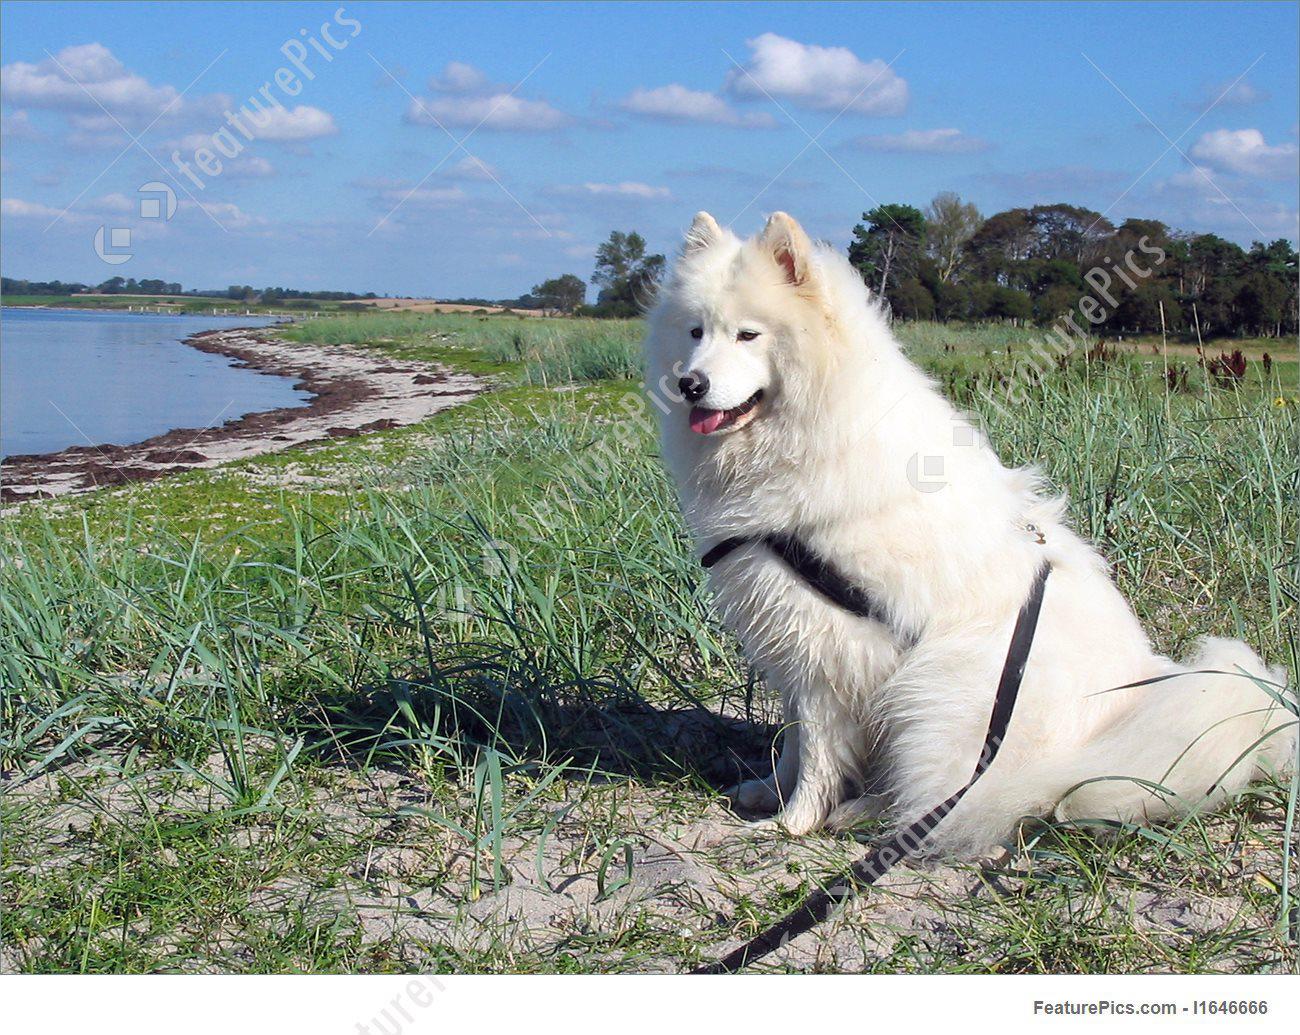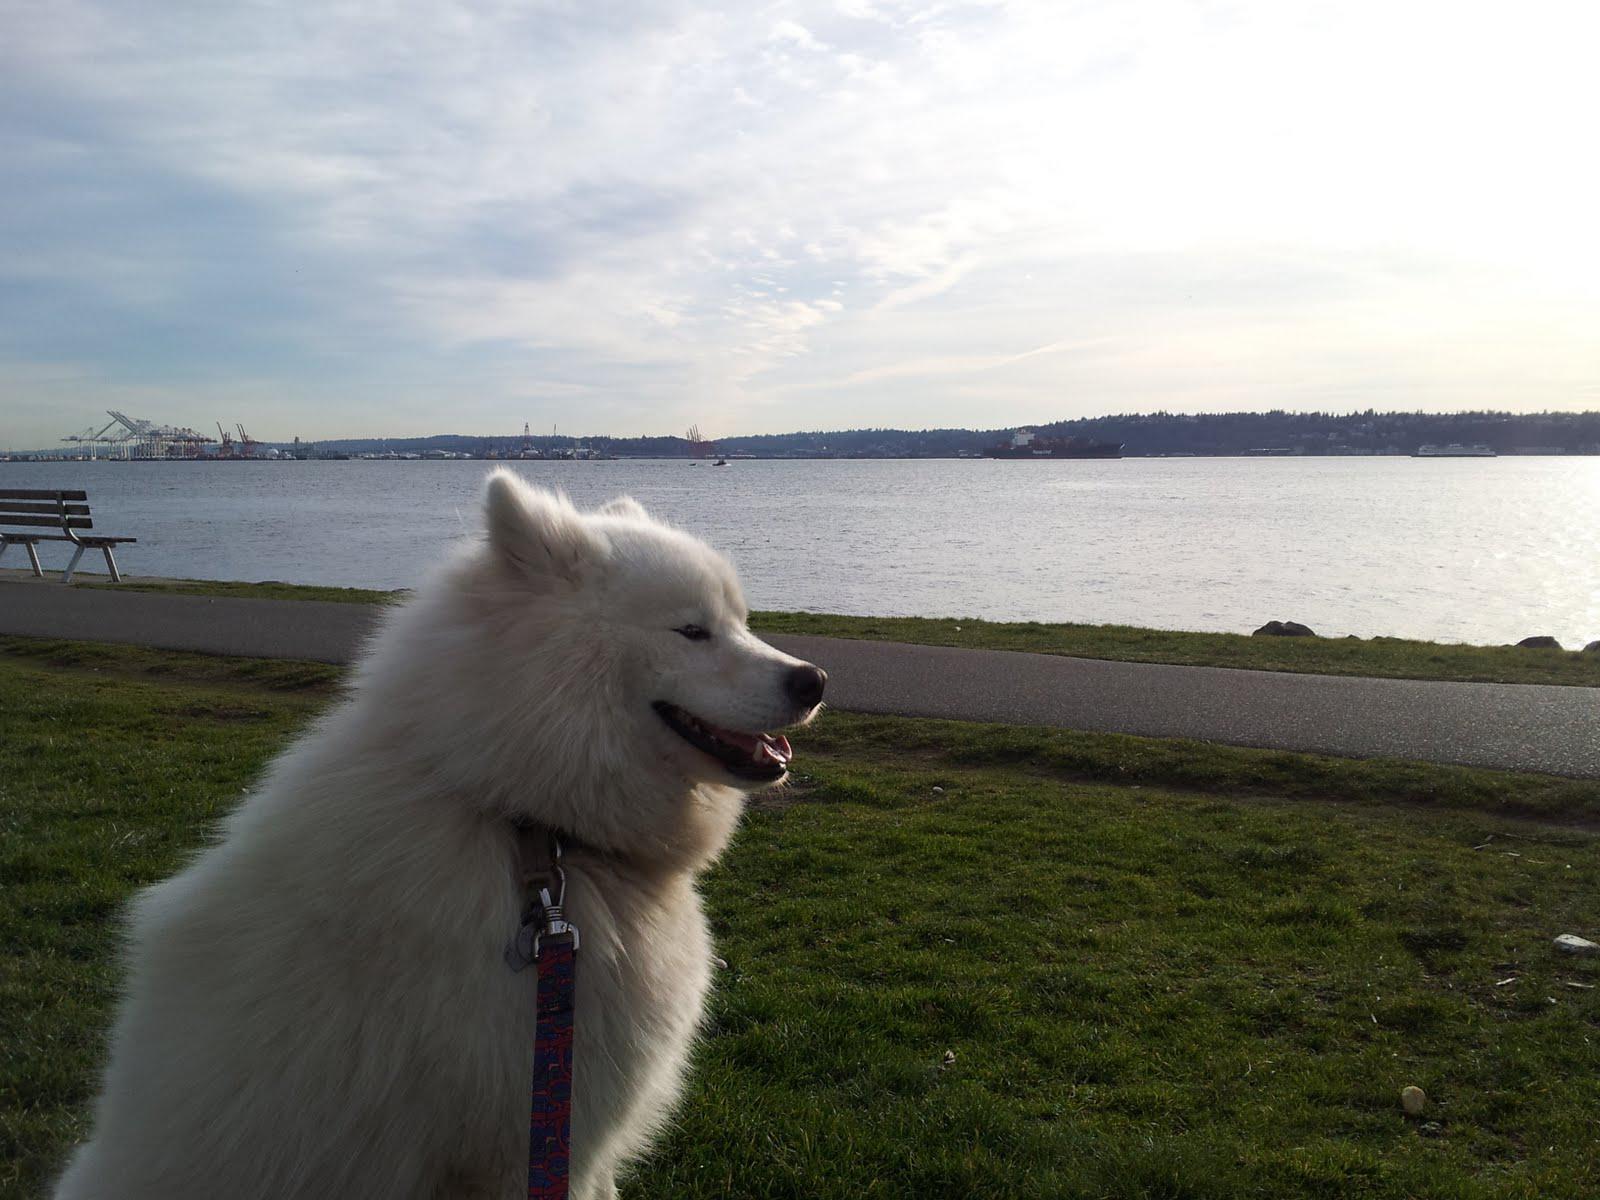The first image is the image on the left, the second image is the image on the right. Considering the images on both sides, is "Each of two dogs at an outdoor grassy location has its mouth open with tongue showing and is wearing a leash." valid? Answer yes or no. Yes. The first image is the image on the left, the second image is the image on the right. Assess this claim about the two images: "One image shows a dog in a harness standing with head and body in profile, without a leash visible, and the other image shows a dog without a leash or harness.". Correct or not? Answer yes or no. No. 